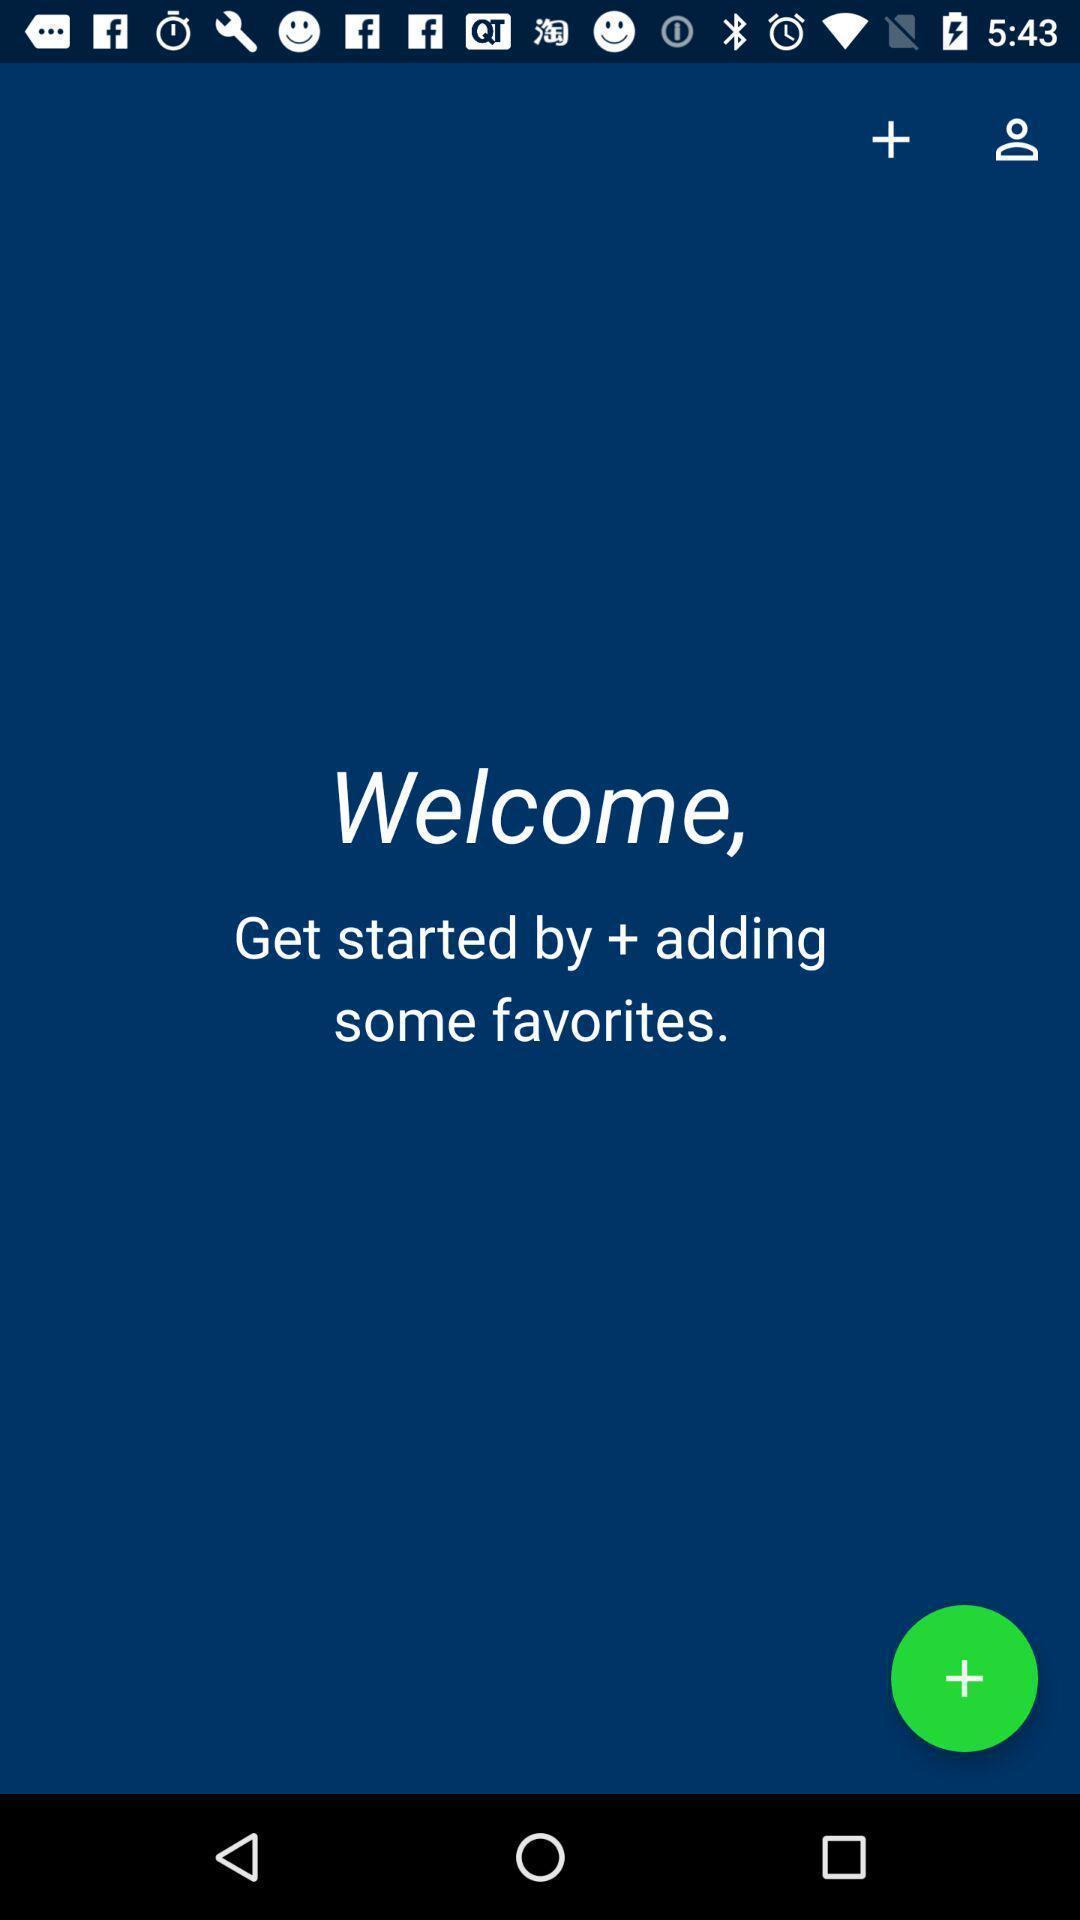Give me a narrative description of this picture. Welcome page showing to add favorites in social app. 